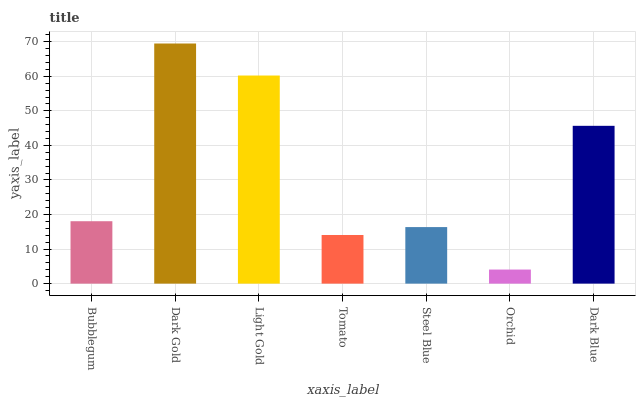Is Orchid the minimum?
Answer yes or no. Yes. Is Dark Gold the maximum?
Answer yes or no. Yes. Is Light Gold the minimum?
Answer yes or no. No. Is Light Gold the maximum?
Answer yes or no. No. Is Dark Gold greater than Light Gold?
Answer yes or no. Yes. Is Light Gold less than Dark Gold?
Answer yes or no. Yes. Is Light Gold greater than Dark Gold?
Answer yes or no. No. Is Dark Gold less than Light Gold?
Answer yes or no. No. Is Bubblegum the high median?
Answer yes or no. Yes. Is Bubblegum the low median?
Answer yes or no. Yes. Is Tomato the high median?
Answer yes or no. No. Is Orchid the low median?
Answer yes or no. No. 